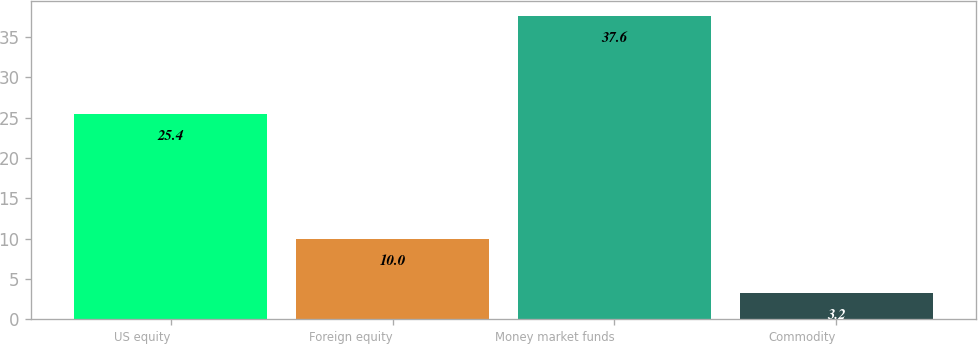Convert chart to OTSL. <chart><loc_0><loc_0><loc_500><loc_500><bar_chart><fcel>US equity<fcel>Foreign equity<fcel>Money market funds<fcel>Commodity<nl><fcel>25.4<fcel>10<fcel>37.6<fcel>3.2<nl></chart> 